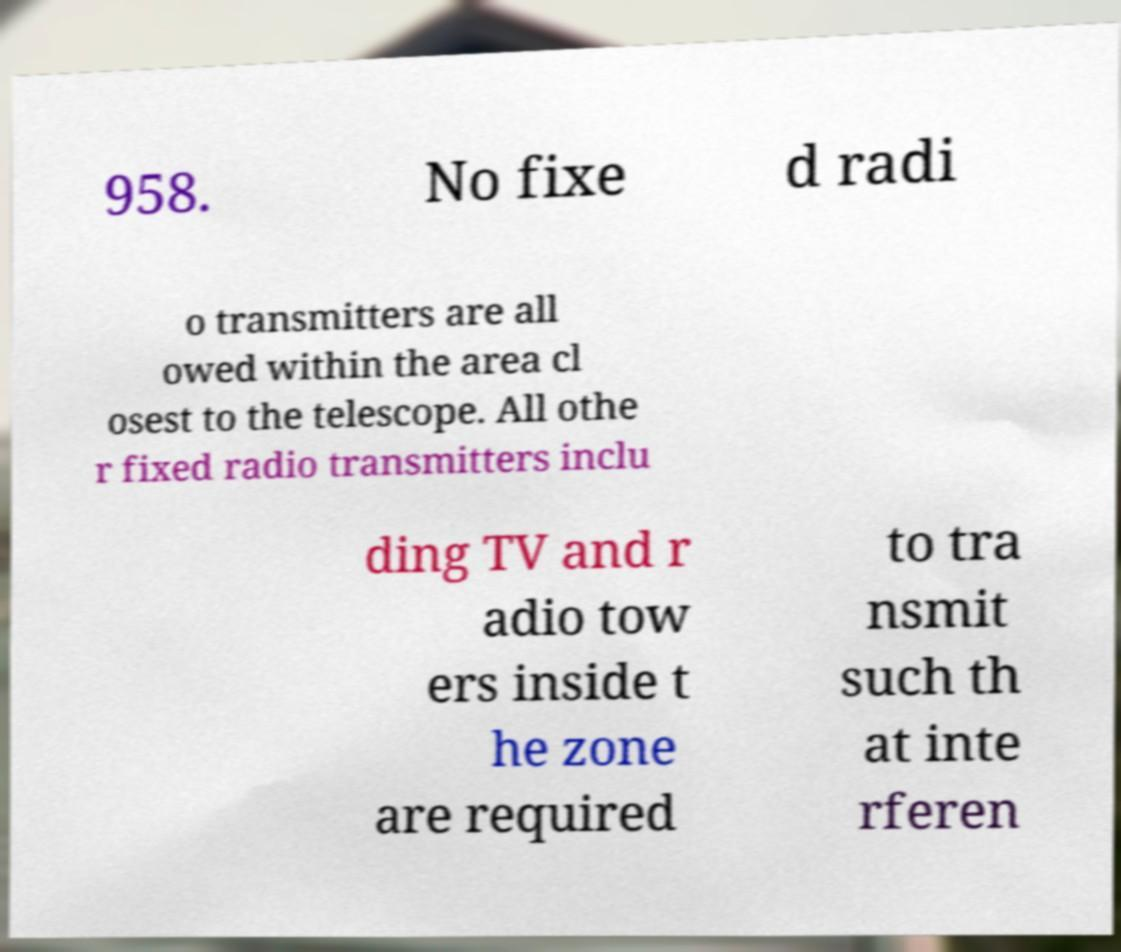Please identify and transcribe the text found in this image. 958. No fixe d radi o transmitters are all owed within the area cl osest to the telescope. All othe r fixed radio transmitters inclu ding TV and r adio tow ers inside t he zone are required to tra nsmit such th at inte rferen 